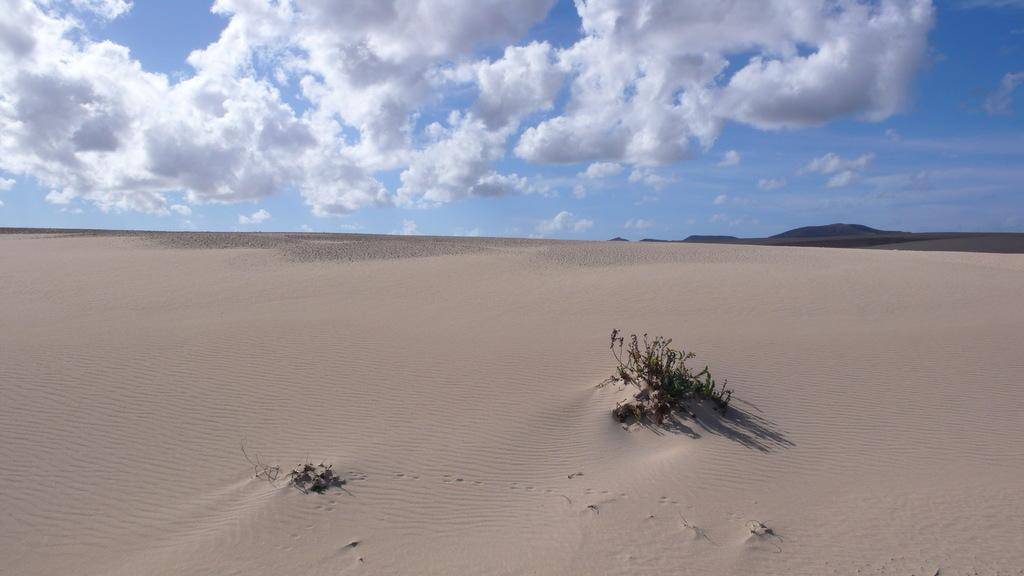What type of vegetation is present in the image? There is a plant in the image. What type of terrain can be seen in the image? There is sand and hills visible in the image. What is visible at the top of the image? The sky is visible at the top of the image. Where is the prison located in the image? There is no prison present in the image. What type of pen is used to draw the hills in the image? There is no pen or drawing in the image; it is a photograph of a natural landscape. 